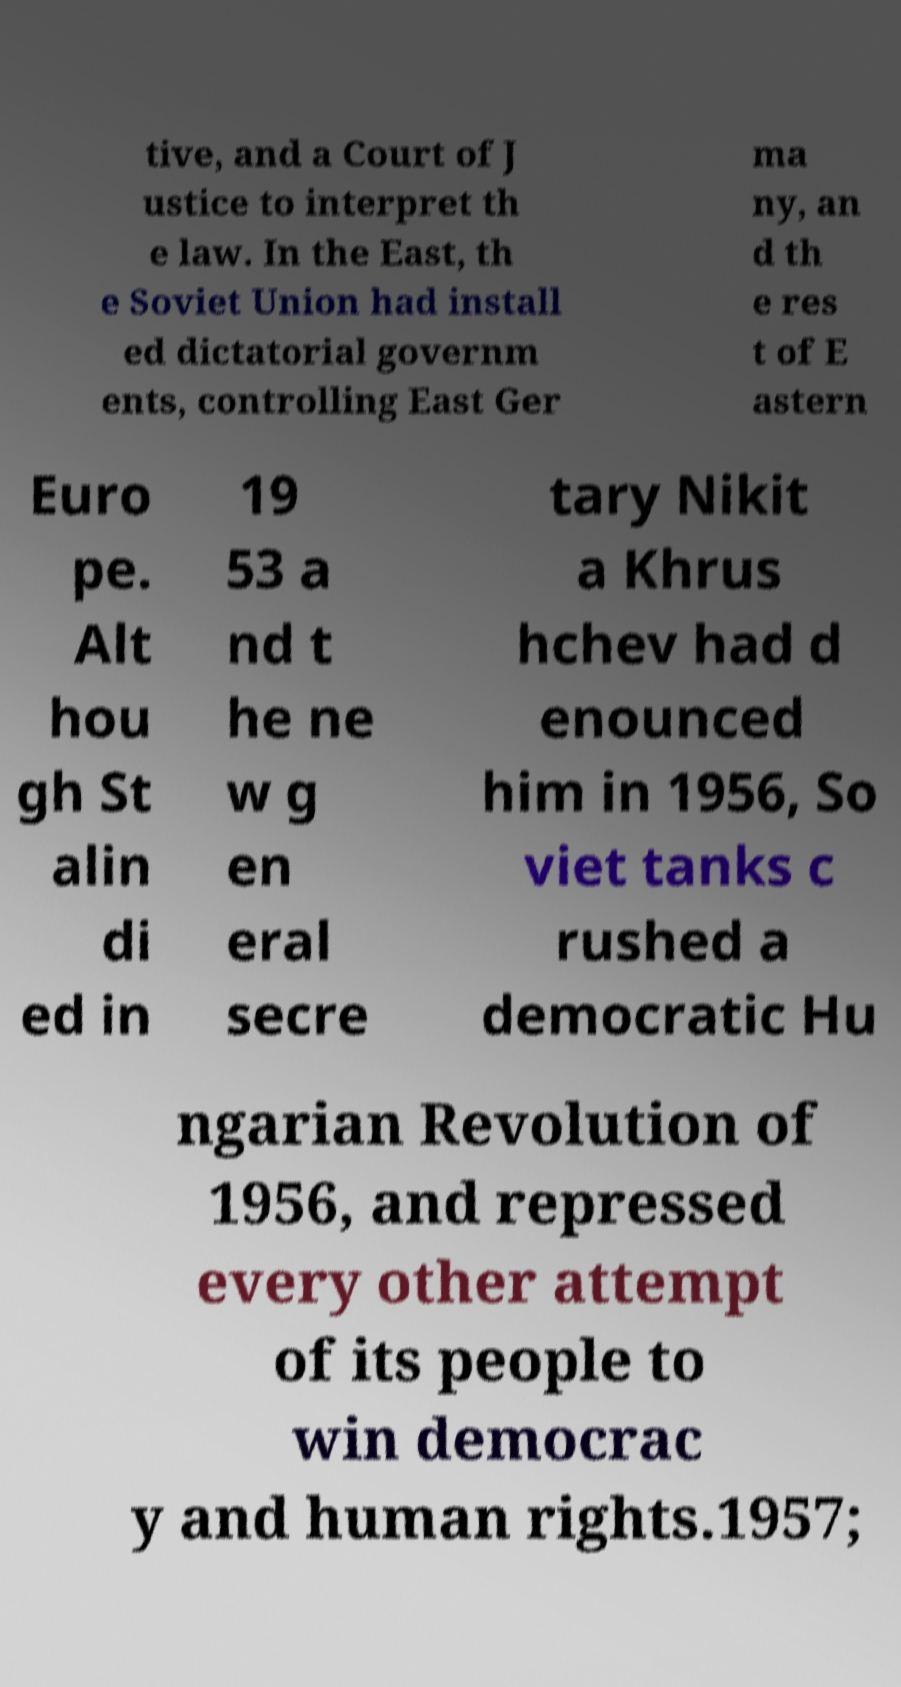I need the written content from this picture converted into text. Can you do that? tive, and a Court of J ustice to interpret th e law. In the East, th e Soviet Union had install ed dictatorial governm ents, controlling East Ger ma ny, an d th e res t of E astern Euro pe. Alt hou gh St alin di ed in 19 53 a nd t he ne w g en eral secre tary Nikit a Khrus hchev had d enounced him in 1956, So viet tanks c rushed a democratic Hu ngarian Revolution of 1956, and repressed every other attempt of its people to win democrac y and human rights.1957; 